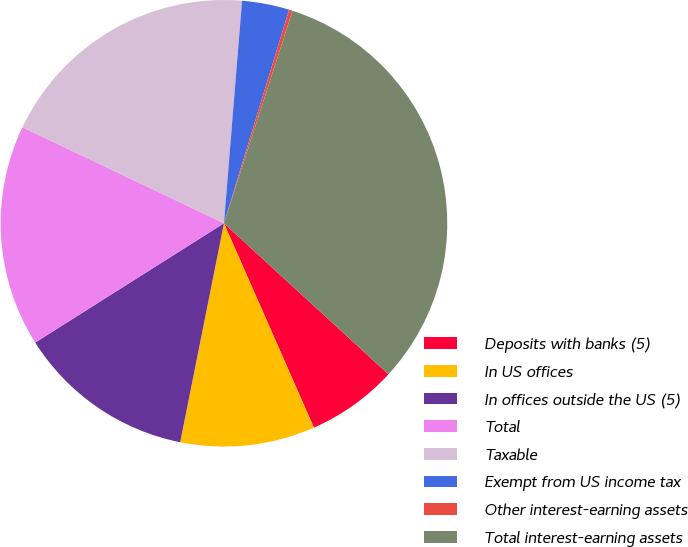<chart> <loc_0><loc_0><loc_500><loc_500><pie_chart><fcel>Deposits with banks (5)<fcel>In US offices<fcel>In offices outside the US (5)<fcel>Total<fcel>Taxable<fcel>Exempt from US income tax<fcel>Other interest-earning assets<fcel>Total interest-earning assets<nl><fcel>6.58%<fcel>9.74%<fcel>12.89%<fcel>16.05%<fcel>19.21%<fcel>3.42%<fcel>0.26%<fcel>31.85%<nl></chart> 